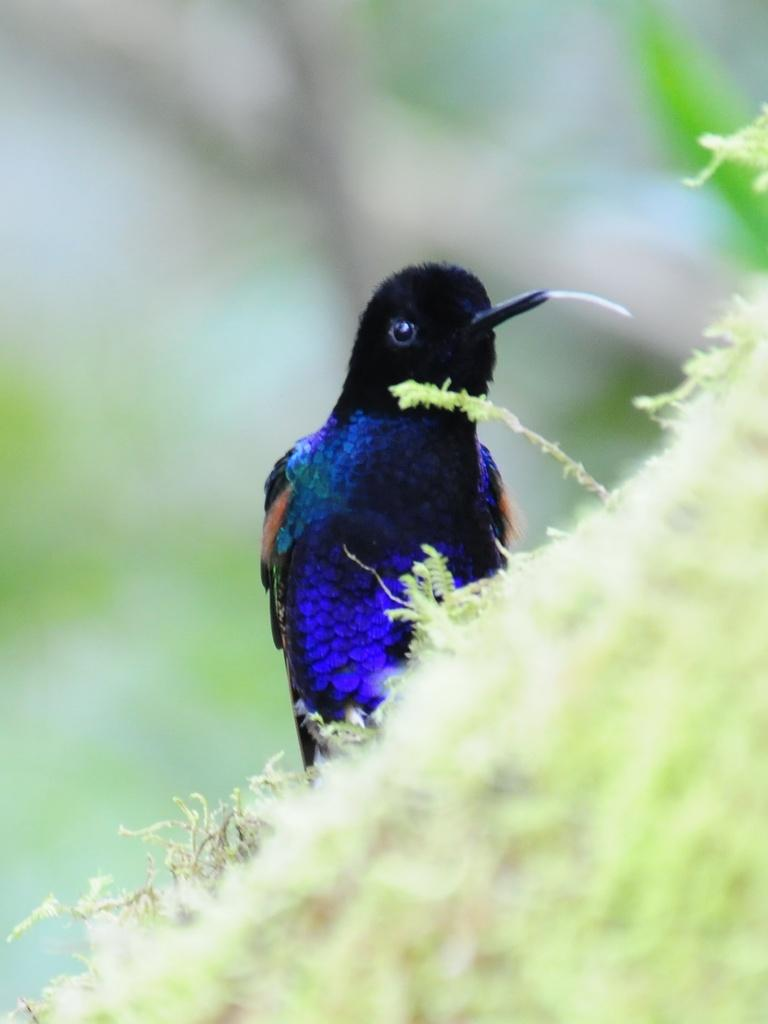What is the main subject in the foreground of the image? There is a beautiful bird in the foreground of the image. What is the bird standing on? The bird is on greenery. What is the bird holding or carrying in its mouth? The bird has something in its mouth. How would you describe the background of the image? The background of the image is blurred. What type of plantation can be seen in the background of the image? There is no plantation visible in the image; the background is blurred. How does the crook interact with the bird in the image? There is no crook present in the image, so it cannot interact with the bird. 